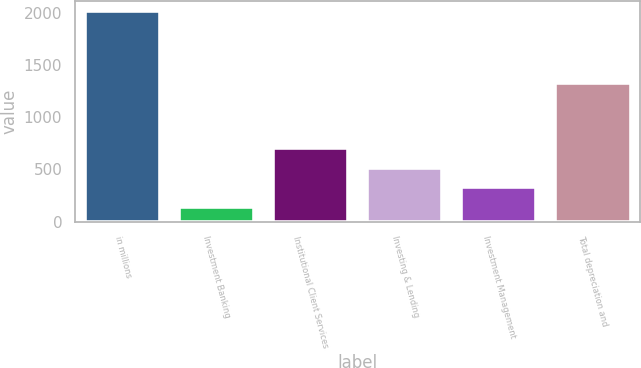Convert chart. <chart><loc_0><loc_0><loc_500><loc_500><bar_chart><fcel>in millions<fcel>Investment Banking<fcel>Institutional Client Services<fcel>Investing & Lending<fcel>Investment Management<fcel>Total depreciation and<nl><fcel>2013<fcel>144<fcel>704.7<fcel>517.8<fcel>330.9<fcel>1322<nl></chart> 